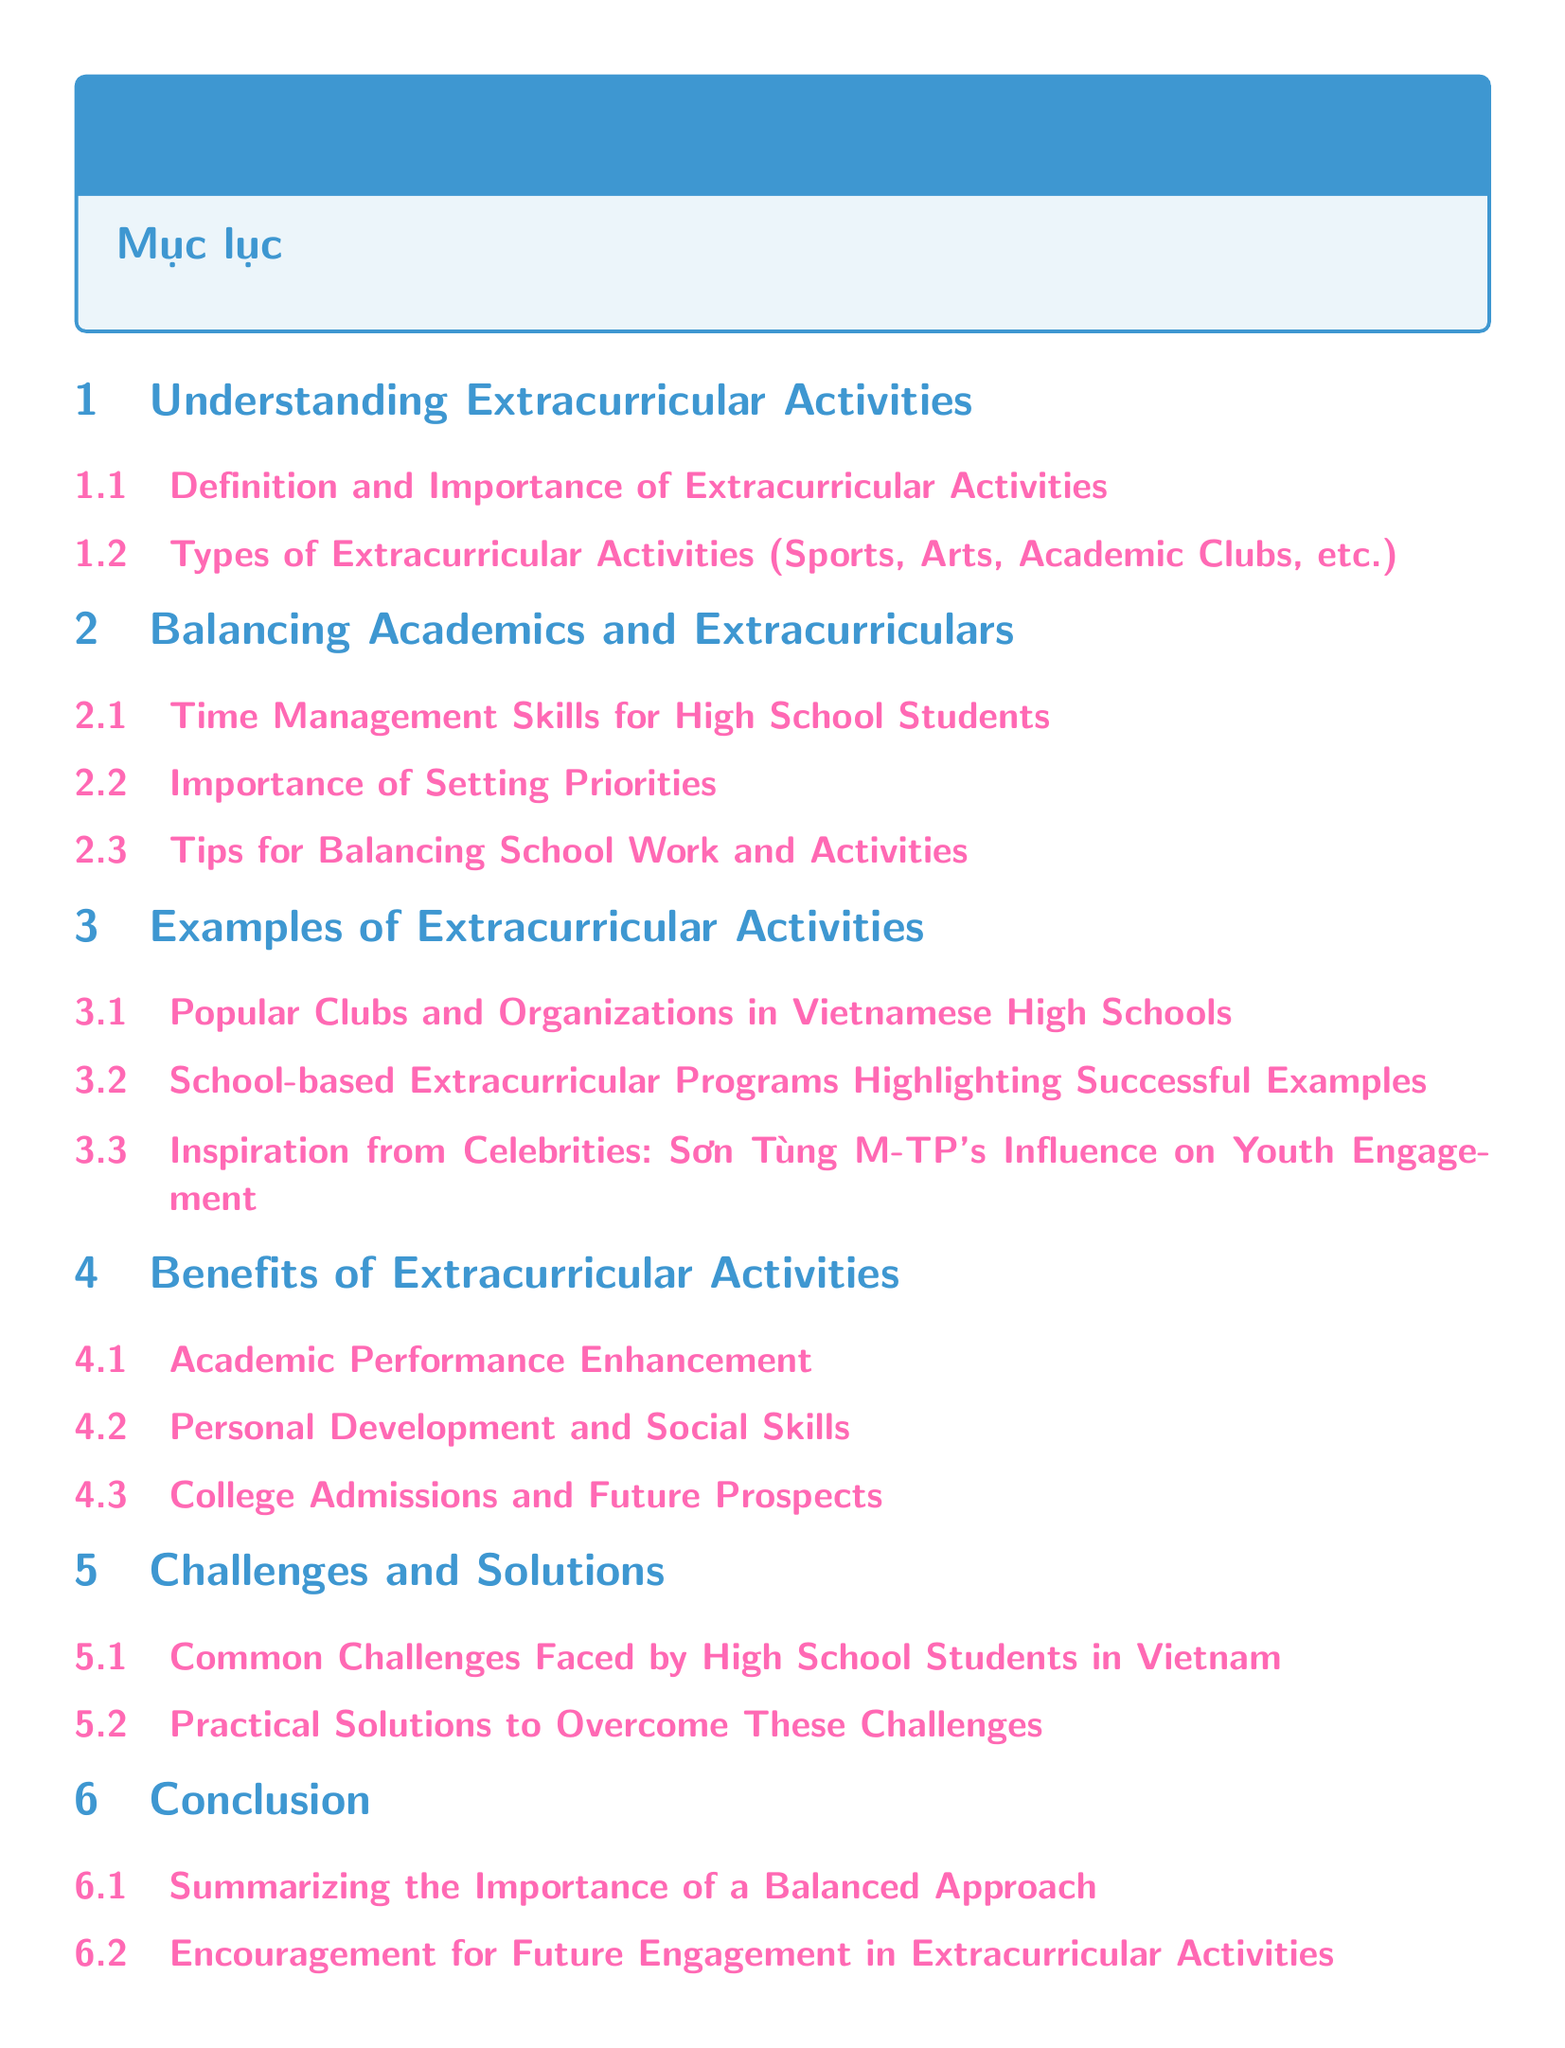What is the main topic of the document? The main topic is summarized in the title, which is "Extracurricular Activities for High School Students: Balancing Interests and Academics."
Answer: Extracurricular Activities for High School Students: Balancing Interests and Academics What section discusses time management? This information is found in the section titled "Balancing Academics and Extracurriculars," specifically under the subsection "Time Management Skills for High School Students."
Answer: Time Management Skills for High School Students How many subsections are under "Benefits of Extracurricular Activities"? The section has three subsections listed, indicating the number of subsections.
Answer: 3 Which Vietnamese celebrity is mentioned in the document? The document highlights "Sơn Tùng M-TP" in the subsection concerning inspiration from celebrities.
Answer: Sơn Tùng M-TP What are the two main challenges faced by students in Vietnam? The document addresses "Common Challenges Faced by High School Students in Vietnam" in the section titled "Challenges and Solutions."
Answer: Common Challenges Faced by High School Students in Vietnam What is the concluding section about? The last section includes a summary and encouragement regarding the importance of extracurricular activities.
Answer: Summarizing the Importance of a Balanced Approach What is an example of an extracurricular activity type? The document lists "Sports" as one of the types under "Types of Extracurricular Activities."
Answer: Sports What is emphasized as important for balancing academics? The document emphasizes "Setting Priorities" as crucial in the corresponding subsection.
Answer: Setting Priorities 